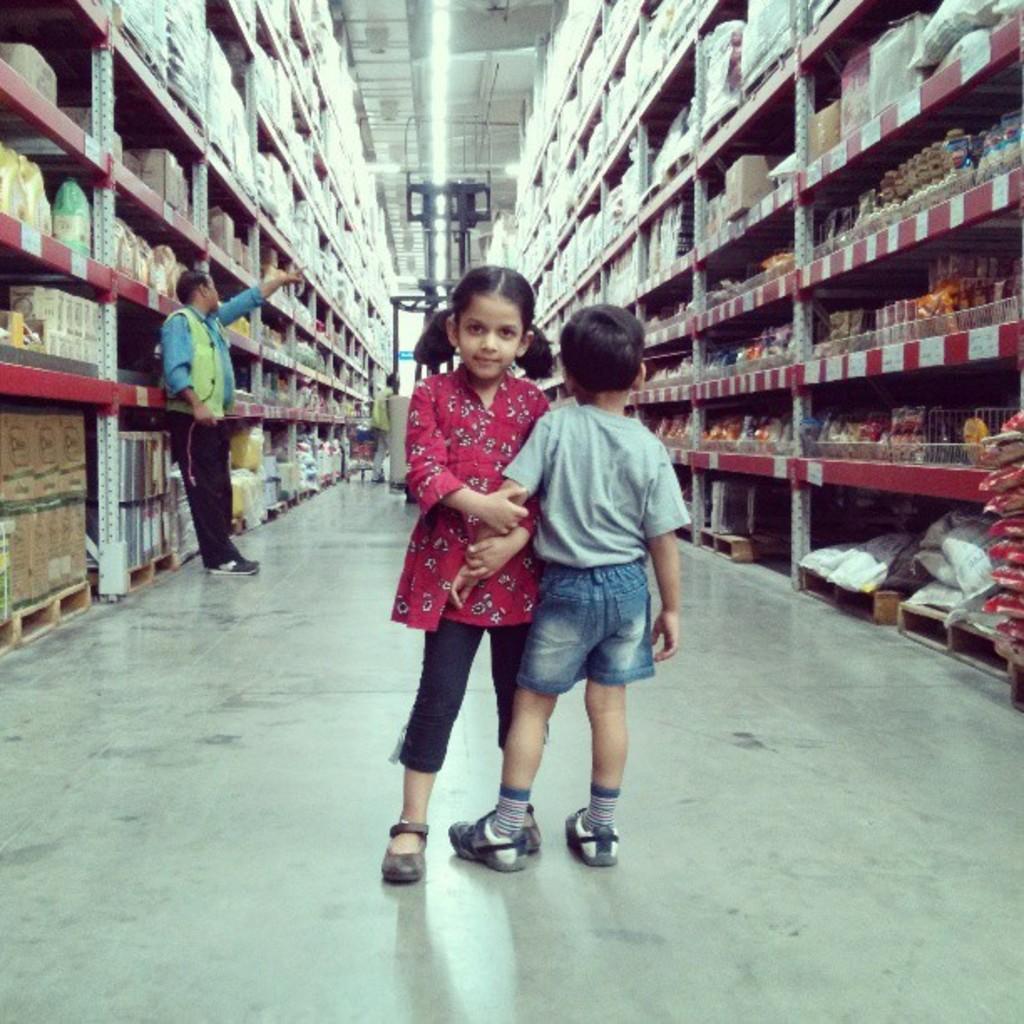Could you give a brief overview of what you see in this image? In this picture there are two kids who are standing on the floor. On the left there is a man who is standing near to the racks. In the racks I can see many cotton boxes, packets and other objects. In the back I can see the trolley. 